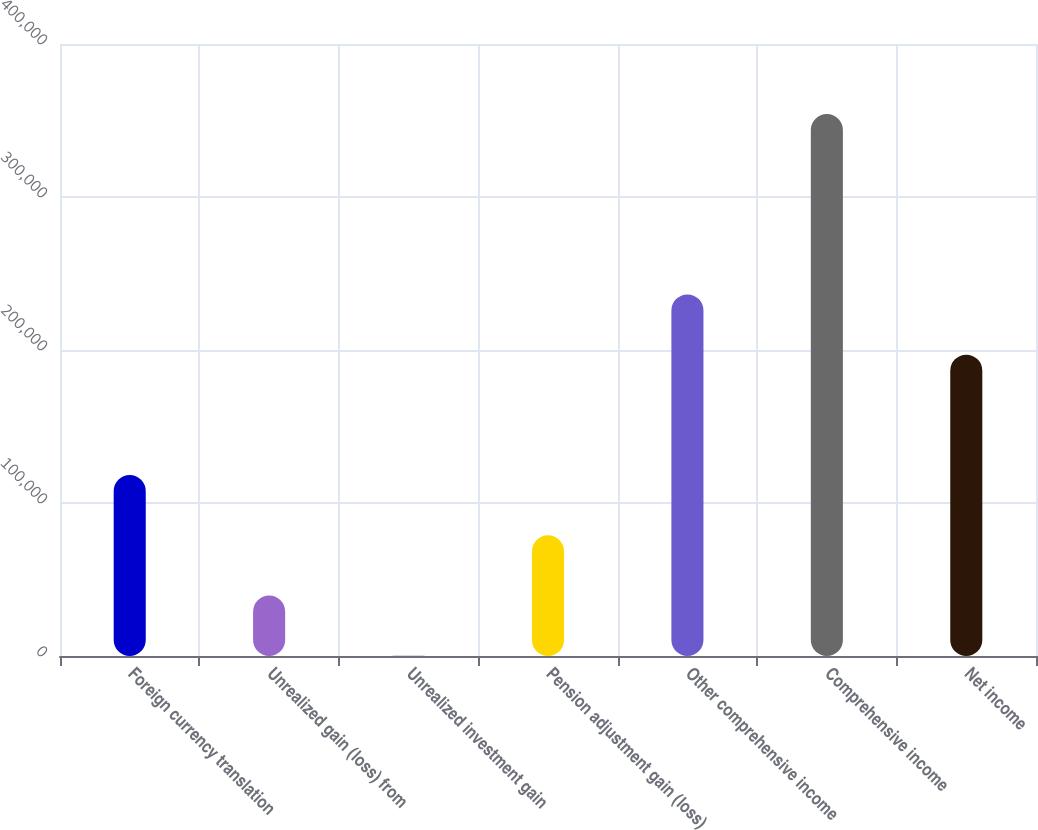Convert chart. <chart><loc_0><loc_0><loc_500><loc_500><bar_chart><fcel>Foreign currency translation<fcel>Unrealized gain (loss) from<fcel>Unrealized investment gain<fcel>Pension adjustment gain (loss)<fcel>Other comprehensive income<fcel>Comprehensive income<fcel>Net income<nl><fcel>118231<fcel>39499.6<fcel>134<fcel>78865.2<fcel>236328<fcel>354251<fcel>196962<nl></chart> 